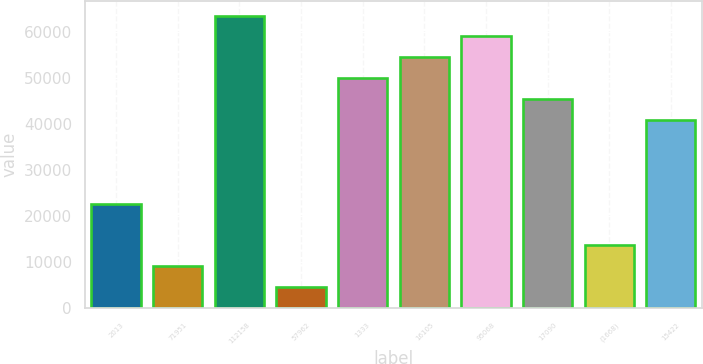Convert chart to OTSL. <chart><loc_0><loc_0><loc_500><loc_500><bar_chart><fcel>2013<fcel>71951<fcel>112158<fcel>57962<fcel>1333<fcel>16105<fcel>95068<fcel>17090<fcel>(1668)<fcel>15422<nl><fcel>22713.5<fcel>9123.2<fcel>63484.4<fcel>4593.1<fcel>49894.1<fcel>54424.2<fcel>58954.3<fcel>45364<fcel>13653.3<fcel>40833.9<nl></chart> 